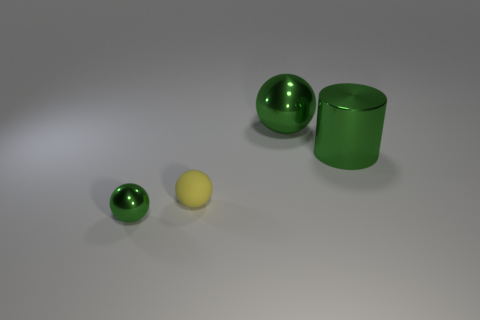Add 3 small metal balls. How many objects exist? 7 Subtract all cylinders. How many objects are left? 3 Add 1 small yellow balls. How many small yellow balls are left? 2 Add 1 small gray matte spheres. How many small gray matte spheres exist? 1 Subtract 0 purple cubes. How many objects are left? 4 Subtract all small yellow blocks. Subtract all rubber things. How many objects are left? 3 